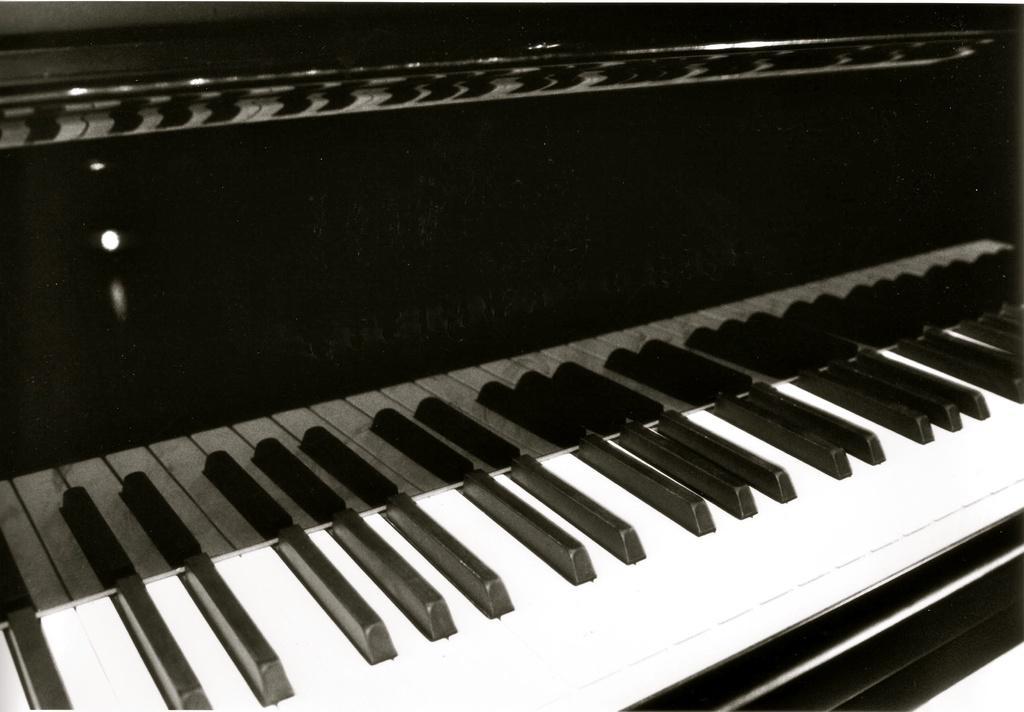Please provide a concise description of this image. This is a picture of a piano, the piano has the black and white keys to play the music. This is a piano box which is in black color. 